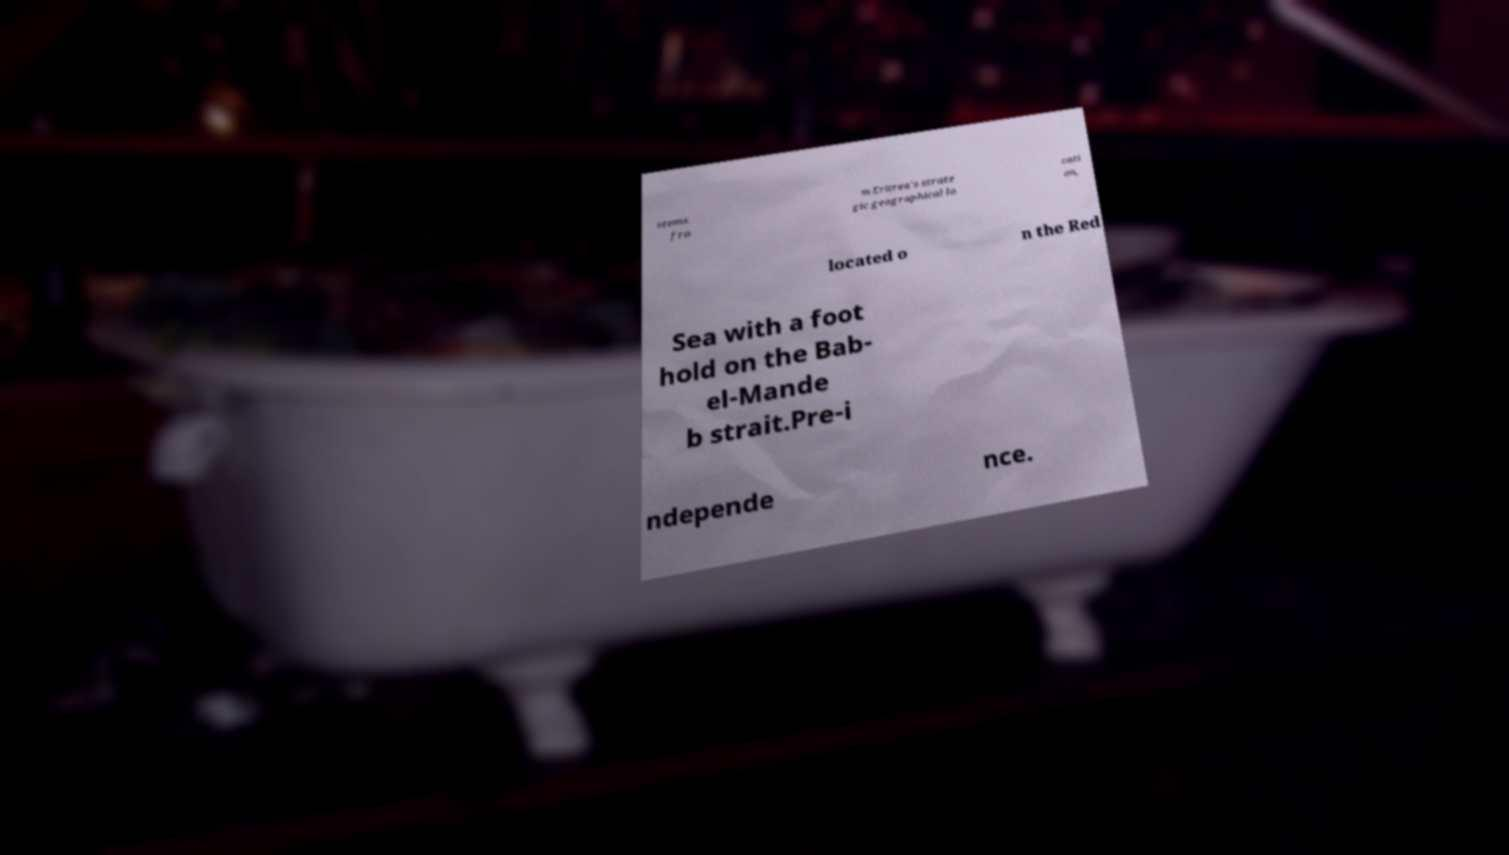Please identify and transcribe the text found in this image. stems fro m Eritrea's strate gic geographical lo cati on, located o n the Red Sea with a foot hold on the Bab- el-Mande b strait.Pre-i ndepende nce. 